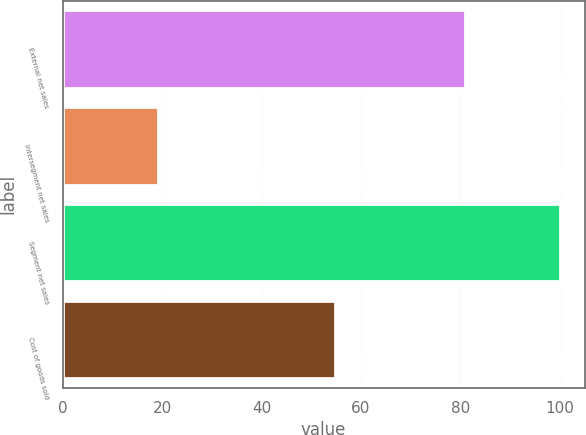<chart> <loc_0><loc_0><loc_500><loc_500><bar_chart><fcel>External net sales<fcel>Intersegment net sales<fcel>Segment net sales<fcel>Cost of goods sold<nl><fcel>80.9<fcel>19.1<fcel>100<fcel>54.8<nl></chart> 